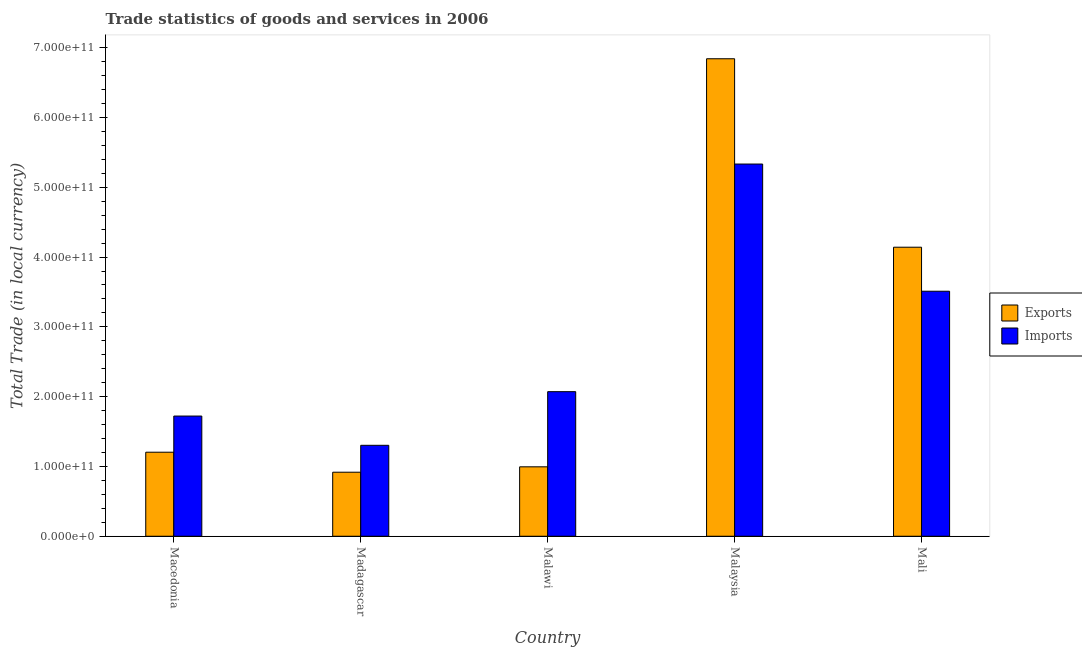Are the number of bars on each tick of the X-axis equal?
Your response must be concise. Yes. What is the label of the 4th group of bars from the left?
Offer a terse response. Malaysia. What is the imports of goods and services in Malaysia?
Offer a terse response. 5.33e+11. Across all countries, what is the maximum imports of goods and services?
Keep it short and to the point. 5.33e+11. Across all countries, what is the minimum export of goods and services?
Give a very brief answer. 9.18e+1. In which country was the export of goods and services maximum?
Give a very brief answer. Malaysia. In which country was the imports of goods and services minimum?
Your answer should be compact. Madagascar. What is the total imports of goods and services in the graph?
Keep it short and to the point. 1.39e+12. What is the difference between the imports of goods and services in Madagascar and that in Malaysia?
Provide a succinct answer. -4.03e+11. What is the difference between the imports of goods and services in Madagascar and the export of goods and services in Mali?
Your answer should be compact. -2.84e+11. What is the average imports of goods and services per country?
Your response must be concise. 2.79e+11. What is the difference between the export of goods and services and imports of goods and services in Macedonia?
Offer a very short reply. -5.18e+1. In how many countries, is the imports of goods and services greater than 520000000000 LCU?
Provide a succinct answer. 1. What is the ratio of the export of goods and services in Malawi to that in Mali?
Make the answer very short. 0.24. Is the imports of goods and services in Malawi less than that in Malaysia?
Your answer should be very brief. Yes. Is the difference between the imports of goods and services in Malawi and Malaysia greater than the difference between the export of goods and services in Malawi and Malaysia?
Your answer should be compact. Yes. What is the difference between the highest and the second highest export of goods and services?
Offer a very short reply. 2.70e+11. What is the difference between the highest and the lowest export of goods and services?
Offer a very short reply. 5.92e+11. In how many countries, is the export of goods and services greater than the average export of goods and services taken over all countries?
Offer a terse response. 2. What does the 1st bar from the left in Mali represents?
Your answer should be compact. Exports. What does the 1st bar from the right in Madagascar represents?
Your answer should be very brief. Imports. How many bars are there?
Your answer should be very brief. 10. How many countries are there in the graph?
Give a very brief answer. 5. What is the difference between two consecutive major ticks on the Y-axis?
Your answer should be compact. 1.00e+11. Are the values on the major ticks of Y-axis written in scientific E-notation?
Make the answer very short. Yes. Does the graph contain grids?
Provide a succinct answer. No. Where does the legend appear in the graph?
Your answer should be very brief. Center right. How many legend labels are there?
Provide a succinct answer. 2. What is the title of the graph?
Offer a very short reply. Trade statistics of goods and services in 2006. Does "Merchandise imports" appear as one of the legend labels in the graph?
Keep it short and to the point. No. What is the label or title of the X-axis?
Ensure brevity in your answer.  Country. What is the label or title of the Y-axis?
Ensure brevity in your answer.  Total Trade (in local currency). What is the Total Trade (in local currency) of Exports in Macedonia?
Your answer should be compact. 1.20e+11. What is the Total Trade (in local currency) of Imports in Macedonia?
Your response must be concise. 1.72e+11. What is the Total Trade (in local currency) in Exports in Madagascar?
Offer a terse response. 9.18e+1. What is the Total Trade (in local currency) of Imports in Madagascar?
Give a very brief answer. 1.30e+11. What is the Total Trade (in local currency) of Exports in Malawi?
Offer a terse response. 9.95e+1. What is the Total Trade (in local currency) of Imports in Malawi?
Provide a short and direct response. 2.07e+11. What is the Total Trade (in local currency) of Exports in Malaysia?
Your answer should be very brief. 6.84e+11. What is the Total Trade (in local currency) of Imports in Malaysia?
Provide a short and direct response. 5.33e+11. What is the Total Trade (in local currency) in Exports in Mali?
Provide a short and direct response. 4.14e+11. What is the Total Trade (in local currency) in Imports in Mali?
Offer a terse response. 3.51e+11. Across all countries, what is the maximum Total Trade (in local currency) of Exports?
Ensure brevity in your answer.  6.84e+11. Across all countries, what is the maximum Total Trade (in local currency) of Imports?
Ensure brevity in your answer.  5.33e+11. Across all countries, what is the minimum Total Trade (in local currency) in Exports?
Offer a terse response. 9.18e+1. Across all countries, what is the minimum Total Trade (in local currency) of Imports?
Give a very brief answer. 1.30e+11. What is the total Total Trade (in local currency) in Exports in the graph?
Ensure brevity in your answer.  1.41e+12. What is the total Total Trade (in local currency) in Imports in the graph?
Make the answer very short. 1.39e+12. What is the difference between the Total Trade (in local currency) of Exports in Macedonia and that in Madagascar?
Ensure brevity in your answer.  2.86e+1. What is the difference between the Total Trade (in local currency) in Imports in Macedonia and that in Madagascar?
Your answer should be very brief. 4.19e+1. What is the difference between the Total Trade (in local currency) of Exports in Macedonia and that in Malawi?
Offer a terse response. 2.09e+1. What is the difference between the Total Trade (in local currency) in Imports in Macedonia and that in Malawi?
Keep it short and to the point. -3.49e+1. What is the difference between the Total Trade (in local currency) in Exports in Macedonia and that in Malaysia?
Offer a terse response. -5.64e+11. What is the difference between the Total Trade (in local currency) in Imports in Macedonia and that in Malaysia?
Offer a terse response. -3.61e+11. What is the difference between the Total Trade (in local currency) of Exports in Macedonia and that in Mali?
Ensure brevity in your answer.  -2.94e+11. What is the difference between the Total Trade (in local currency) in Imports in Macedonia and that in Mali?
Give a very brief answer. -1.79e+11. What is the difference between the Total Trade (in local currency) of Exports in Madagascar and that in Malawi?
Provide a succinct answer. -7.71e+09. What is the difference between the Total Trade (in local currency) in Imports in Madagascar and that in Malawi?
Your answer should be very brief. -7.69e+1. What is the difference between the Total Trade (in local currency) of Exports in Madagascar and that in Malaysia?
Your response must be concise. -5.92e+11. What is the difference between the Total Trade (in local currency) of Imports in Madagascar and that in Malaysia?
Your answer should be very brief. -4.03e+11. What is the difference between the Total Trade (in local currency) of Exports in Madagascar and that in Mali?
Provide a succinct answer. -3.22e+11. What is the difference between the Total Trade (in local currency) of Imports in Madagascar and that in Mali?
Provide a succinct answer. -2.21e+11. What is the difference between the Total Trade (in local currency) in Exports in Malawi and that in Malaysia?
Make the answer very short. -5.85e+11. What is the difference between the Total Trade (in local currency) in Imports in Malawi and that in Malaysia?
Your answer should be compact. -3.26e+11. What is the difference between the Total Trade (in local currency) in Exports in Malawi and that in Mali?
Offer a very short reply. -3.15e+11. What is the difference between the Total Trade (in local currency) of Imports in Malawi and that in Mali?
Your response must be concise. -1.44e+11. What is the difference between the Total Trade (in local currency) in Exports in Malaysia and that in Mali?
Offer a terse response. 2.70e+11. What is the difference between the Total Trade (in local currency) in Imports in Malaysia and that in Mali?
Give a very brief answer. 1.82e+11. What is the difference between the Total Trade (in local currency) in Exports in Macedonia and the Total Trade (in local currency) in Imports in Madagascar?
Provide a succinct answer. -9.90e+09. What is the difference between the Total Trade (in local currency) in Exports in Macedonia and the Total Trade (in local currency) in Imports in Malawi?
Ensure brevity in your answer.  -8.68e+1. What is the difference between the Total Trade (in local currency) of Exports in Macedonia and the Total Trade (in local currency) of Imports in Malaysia?
Give a very brief answer. -4.13e+11. What is the difference between the Total Trade (in local currency) of Exports in Macedonia and the Total Trade (in local currency) of Imports in Mali?
Give a very brief answer. -2.31e+11. What is the difference between the Total Trade (in local currency) in Exports in Madagascar and the Total Trade (in local currency) in Imports in Malawi?
Offer a terse response. -1.15e+11. What is the difference between the Total Trade (in local currency) of Exports in Madagascar and the Total Trade (in local currency) of Imports in Malaysia?
Provide a succinct answer. -4.42e+11. What is the difference between the Total Trade (in local currency) of Exports in Madagascar and the Total Trade (in local currency) of Imports in Mali?
Offer a terse response. -2.59e+11. What is the difference between the Total Trade (in local currency) of Exports in Malawi and the Total Trade (in local currency) of Imports in Malaysia?
Your answer should be very brief. -4.34e+11. What is the difference between the Total Trade (in local currency) of Exports in Malawi and the Total Trade (in local currency) of Imports in Mali?
Provide a succinct answer. -2.52e+11. What is the difference between the Total Trade (in local currency) of Exports in Malaysia and the Total Trade (in local currency) of Imports in Mali?
Offer a terse response. 3.33e+11. What is the average Total Trade (in local currency) of Exports per country?
Offer a terse response. 2.82e+11. What is the average Total Trade (in local currency) in Imports per country?
Offer a very short reply. 2.79e+11. What is the difference between the Total Trade (in local currency) of Exports and Total Trade (in local currency) of Imports in Macedonia?
Offer a terse response. -5.18e+1. What is the difference between the Total Trade (in local currency) in Exports and Total Trade (in local currency) in Imports in Madagascar?
Your answer should be very brief. -3.85e+1. What is the difference between the Total Trade (in local currency) of Exports and Total Trade (in local currency) of Imports in Malawi?
Provide a short and direct response. -1.08e+11. What is the difference between the Total Trade (in local currency) of Exports and Total Trade (in local currency) of Imports in Malaysia?
Offer a very short reply. 1.51e+11. What is the difference between the Total Trade (in local currency) of Exports and Total Trade (in local currency) of Imports in Mali?
Offer a terse response. 6.31e+1. What is the ratio of the Total Trade (in local currency) in Exports in Macedonia to that in Madagascar?
Provide a short and direct response. 1.31. What is the ratio of the Total Trade (in local currency) of Imports in Macedonia to that in Madagascar?
Make the answer very short. 1.32. What is the ratio of the Total Trade (in local currency) in Exports in Macedonia to that in Malawi?
Your answer should be very brief. 1.21. What is the ratio of the Total Trade (in local currency) of Imports in Macedonia to that in Malawi?
Provide a succinct answer. 0.83. What is the ratio of the Total Trade (in local currency) in Exports in Macedonia to that in Malaysia?
Make the answer very short. 0.18. What is the ratio of the Total Trade (in local currency) in Imports in Macedonia to that in Malaysia?
Offer a terse response. 0.32. What is the ratio of the Total Trade (in local currency) of Exports in Macedonia to that in Mali?
Ensure brevity in your answer.  0.29. What is the ratio of the Total Trade (in local currency) in Imports in Macedonia to that in Mali?
Your response must be concise. 0.49. What is the ratio of the Total Trade (in local currency) in Exports in Madagascar to that in Malawi?
Give a very brief answer. 0.92. What is the ratio of the Total Trade (in local currency) of Imports in Madagascar to that in Malawi?
Provide a succinct answer. 0.63. What is the ratio of the Total Trade (in local currency) in Exports in Madagascar to that in Malaysia?
Your answer should be very brief. 0.13. What is the ratio of the Total Trade (in local currency) of Imports in Madagascar to that in Malaysia?
Keep it short and to the point. 0.24. What is the ratio of the Total Trade (in local currency) of Exports in Madagascar to that in Mali?
Keep it short and to the point. 0.22. What is the ratio of the Total Trade (in local currency) in Imports in Madagascar to that in Mali?
Ensure brevity in your answer.  0.37. What is the ratio of the Total Trade (in local currency) in Exports in Malawi to that in Malaysia?
Your answer should be very brief. 0.15. What is the ratio of the Total Trade (in local currency) of Imports in Malawi to that in Malaysia?
Offer a terse response. 0.39. What is the ratio of the Total Trade (in local currency) in Exports in Malawi to that in Mali?
Keep it short and to the point. 0.24. What is the ratio of the Total Trade (in local currency) of Imports in Malawi to that in Mali?
Keep it short and to the point. 0.59. What is the ratio of the Total Trade (in local currency) in Exports in Malaysia to that in Mali?
Offer a terse response. 1.65. What is the ratio of the Total Trade (in local currency) of Imports in Malaysia to that in Mali?
Offer a very short reply. 1.52. What is the difference between the highest and the second highest Total Trade (in local currency) in Exports?
Make the answer very short. 2.70e+11. What is the difference between the highest and the second highest Total Trade (in local currency) in Imports?
Ensure brevity in your answer.  1.82e+11. What is the difference between the highest and the lowest Total Trade (in local currency) in Exports?
Your answer should be very brief. 5.92e+11. What is the difference between the highest and the lowest Total Trade (in local currency) in Imports?
Your answer should be compact. 4.03e+11. 